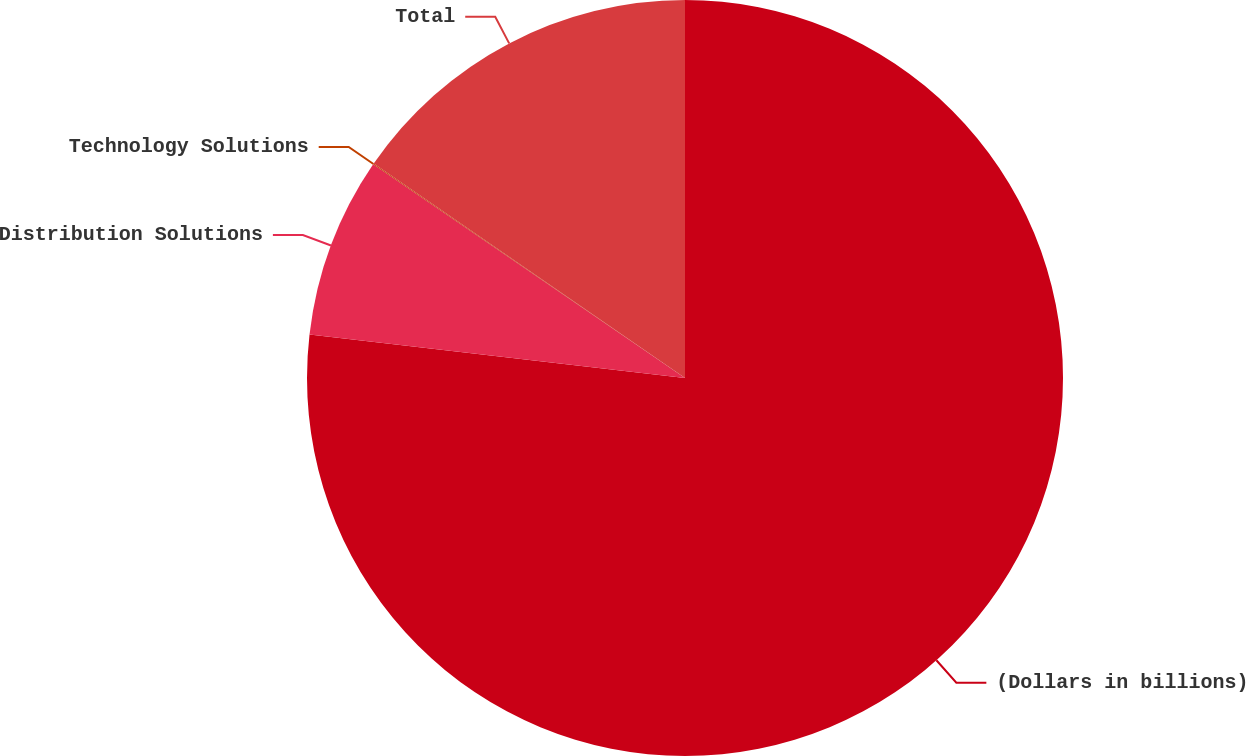Convert chart. <chart><loc_0><loc_0><loc_500><loc_500><pie_chart><fcel>(Dollars in billions)<fcel>Distribution Solutions<fcel>Technology Solutions<fcel>Total<nl><fcel>76.84%<fcel>7.72%<fcel>0.04%<fcel>15.4%<nl></chart> 